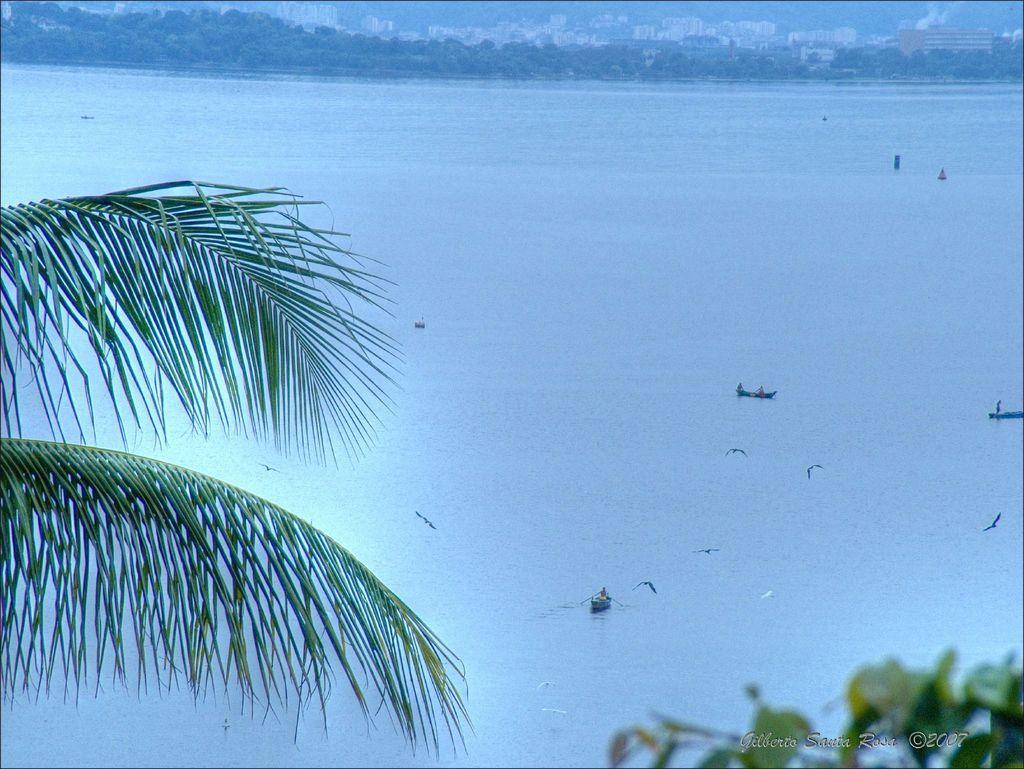How would you summarize this image in a sentence or two? In this picture we can see boats on water, here we can see birds flying and in the background we can see buildings, trees, in the bottom right we can see some text on it. 